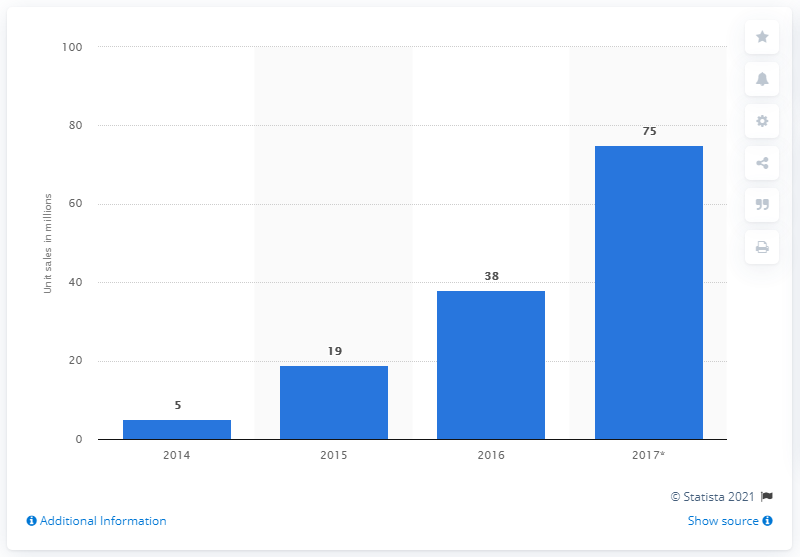Highlight a few significant elements in this photo. According to projections, an estimated 75 million units of smartwatches are expected to be sold worldwide in 2017. According to analysis of smartwatch sales revenue in 2017, the highest earnings were recorded that year in dollars. The highest and lowest sales years differ by 70. 